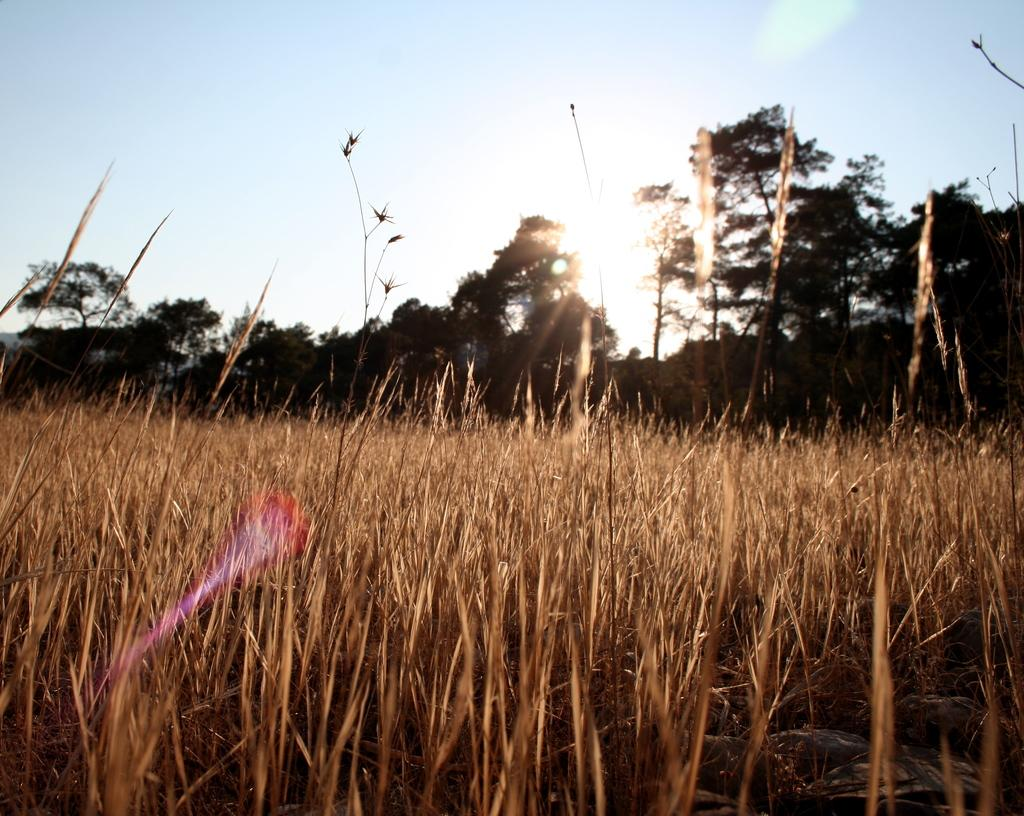What type of vegetation can be seen in the image? There is grass in the image. What is the surface beneath the grass? There is ground visible in the image. What can be seen in the distance in the image? There are trees in the background of the image. What is visible above the trees in the image? The sky is visible in the background of the image. How does the grass sense the presence of the wind in the image? The grass does not sense the presence of the wind in the image; it is a static representation of grass. 